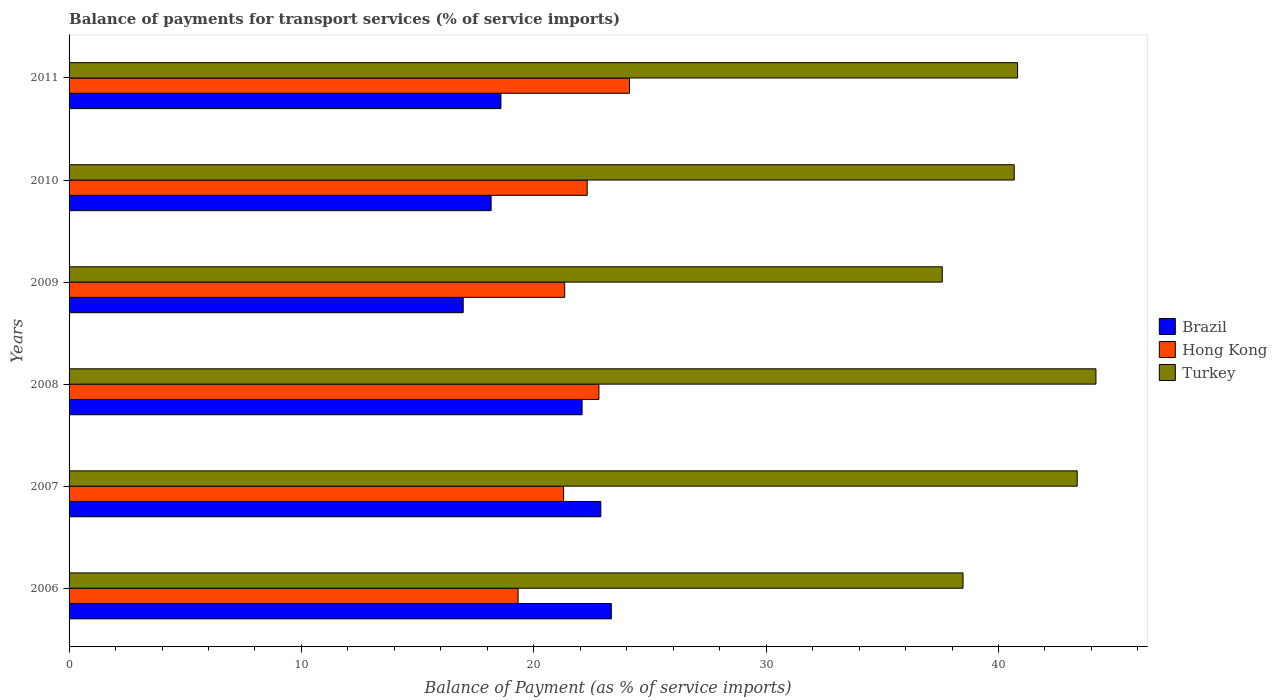How many bars are there on the 3rd tick from the top?
Offer a very short reply. 3. How many bars are there on the 1st tick from the bottom?
Your answer should be very brief. 3. What is the label of the 3rd group of bars from the top?
Make the answer very short. 2009. In how many cases, is the number of bars for a given year not equal to the number of legend labels?
Offer a very short reply. 0. What is the balance of payments for transport services in Brazil in 2007?
Make the answer very short. 22.89. Across all years, what is the maximum balance of payments for transport services in Hong Kong?
Provide a short and direct response. 24.12. Across all years, what is the minimum balance of payments for transport services in Turkey?
Your answer should be compact. 37.58. In which year was the balance of payments for transport services in Brazil maximum?
Make the answer very short. 2006. In which year was the balance of payments for transport services in Hong Kong minimum?
Provide a succinct answer. 2006. What is the total balance of payments for transport services in Hong Kong in the graph?
Keep it short and to the point. 131.16. What is the difference between the balance of payments for transport services in Hong Kong in 2007 and that in 2009?
Offer a terse response. -0.05. What is the difference between the balance of payments for transport services in Brazil in 2011 and the balance of payments for transport services in Hong Kong in 2007?
Give a very brief answer. -2.7. What is the average balance of payments for transport services in Turkey per year?
Offer a very short reply. 40.86. In the year 2011, what is the difference between the balance of payments for transport services in Brazil and balance of payments for transport services in Turkey?
Provide a succinct answer. -22.24. What is the ratio of the balance of payments for transport services in Brazil in 2007 to that in 2008?
Offer a very short reply. 1.04. Is the balance of payments for transport services in Turkey in 2007 less than that in 2011?
Offer a terse response. No. What is the difference between the highest and the second highest balance of payments for transport services in Turkey?
Provide a succinct answer. 0.81. What is the difference between the highest and the lowest balance of payments for transport services in Turkey?
Give a very brief answer. 6.61. What does the 2nd bar from the top in 2008 represents?
Provide a short and direct response. Hong Kong. What does the 2nd bar from the bottom in 2011 represents?
Make the answer very short. Hong Kong. How many bars are there?
Keep it short and to the point. 18. How many years are there in the graph?
Your answer should be very brief. 6. Are the values on the major ticks of X-axis written in scientific E-notation?
Your response must be concise. No. How many legend labels are there?
Your answer should be compact. 3. How are the legend labels stacked?
Make the answer very short. Vertical. What is the title of the graph?
Your answer should be compact. Balance of payments for transport services (% of service imports). What is the label or title of the X-axis?
Make the answer very short. Balance of Payment (as % of service imports). What is the label or title of the Y-axis?
Keep it short and to the point. Years. What is the Balance of Payment (as % of service imports) in Brazil in 2006?
Your response must be concise. 23.34. What is the Balance of Payment (as % of service imports) of Hong Kong in 2006?
Your response must be concise. 19.32. What is the Balance of Payment (as % of service imports) of Turkey in 2006?
Your answer should be very brief. 38.47. What is the Balance of Payment (as % of service imports) in Brazil in 2007?
Offer a very short reply. 22.89. What is the Balance of Payment (as % of service imports) of Hong Kong in 2007?
Give a very brief answer. 21.28. What is the Balance of Payment (as % of service imports) in Turkey in 2007?
Ensure brevity in your answer.  43.39. What is the Balance of Payment (as % of service imports) of Brazil in 2008?
Your answer should be compact. 22.08. What is the Balance of Payment (as % of service imports) in Hong Kong in 2008?
Provide a succinct answer. 22.8. What is the Balance of Payment (as % of service imports) in Turkey in 2008?
Your answer should be very brief. 44.2. What is the Balance of Payment (as % of service imports) in Brazil in 2009?
Make the answer very short. 16.96. What is the Balance of Payment (as % of service imports) of Hong Kong in 2009?
Your answer should be very brief. 21.33. What is the Balance of Payment (as % of service imports) in Turkey in 2009?
Provide a short and direct response. 37.58. What is the Balance of Payment (as % of service imports) in Brazil in 2010?
Give a very brief answer. 18.16. What is the Balance of Payment (as % of service imports) of Hong Kong in 2010?
Your response must be concise. 22.3. What is the Balance of Payment (as % of service imports) in Turkey in 2010?
Provide a short and direct response. 40.68. What is the Balance of Payment (as % of service imports) in Brazil in 2011?
Make the answer very short. 18.59. What is the Balance of Payment (as % of service imports) in Hong Kong in 2011?
Provide a succinct answer. 24.12. What is the Balance of Payment (as % of service imports) of Turkey in 2011?
Offer a very short reply. 40.82. Across all years, what is the maximum Balance of Payment (as % of service imports) in Brazil?
Your answer should be very brief. 23.34. Across all years, what is the maximum Balance of Payment (as % of service imports) of Hong Kong?
Keep it short and to the point. 24.12. Across all years, what is the maximum Balance of Payment (as % of service imports) of Turkey?
Provide a short and direct response. 44.2. Across all years, what is the minimum Balance of Payment (as % of service imports) of Brazil?
Your answer should be very brief. 16.96. Across all years, what is the minimum Balance of Payment (as % of service imports) in Hong Kong?
Ensure brevity in your answer.  19.32. Across all years, what is the minimum Balance of Payment (as % of service imports) in Turkey?
Provide a short and direct response. 37.58. What is the total Balance of Payment (as % of service imports) in Brazil in the graph?
Ensure brevity in your answer.  122.01. What is the total Balance of Payment (as % of service imports) in Hong Kong in the graph?
Make the answer very short. 131.16. What is the total Balance of Payment (as % of service imports) of Turkey in the graph?
Make the answer very short. 245.14. What is the difference between the Balance of Payment (as % of service imports) of Brazil in 2006 and that in 2007?
Your answer should be very brief. 0.45. What is the difference between the Balance of Payment (as % of service imports) in Hong Kong in 2006 and that in 2007?
Offer a terse response. -1.96. What is the difference between the Balance of Payment (as % of service imports) in Turkey in 2006 and that in 2007?
Ensure brevity in your answer.  -4.91. What is the difference between the Balance of Payment (as % of service imports) of Brazil in 2006 and that in 2008?
Your answer should be very brief. 1.26. What is the difference between the Balance of Payment (as % of service imports) in Hong Kong in 2006 and that in 2008?
Offer a very short reply. -3.48. What is the difference between the Balance of Payment (as % of service imports) in Turkey in 2006 and that in 2008?
Keep it short and to the point. -5.72. What is the difference between the Balance of Payment (as % of service imports) in Brazil in 2006 and that in 2009?
Keep it short and to the point. 6.37. What is the difference between the Balance of Payment (as % of service imports) of Hong Kong in 2006 and that in 2009?
Offer a terse response. -2.01. What is the difference between the Balance of Payment (as % of service imports) in Turkey in 2006 and that in 2009?
Give a very brief answer. 0.89. What is the difference between the Balance of Payment (as % of service imports) of Brazil in 2006 and that in 2010?
Your answer should be compact. 5.17. What is the difference between the Balance of Payment (as % of service imports) in Hong Kong in 2006 and that in 2010?
Your response must be concise. -2.97. What is the difference between the Balance of Payment (as % of service imports) in Turkey in 2006 and that in 2010?
Provide a succinct answer. -2.2. What is the difference between the Balance of Payment (as % of service imports) of Brazil in 2006 and that in 2011?
Provide a succinct answer. 4.75. What is the difference between the Balance of Payment (as % of service imports) in Hong Kong in 2006 and that in 2011?
Ensure brevity in your answer.  -4.79. What is the difference between the Balance of Payment (as % of service imports) in Turkey in 2006 and that in 2011?
Keep it short and to the point. -2.35. What is the difference between the Balance of Payment (as % of service imports) in Brazil in 2007 and that in 2008?
Ensure brevity in your answer.  0.81. What is the difference between the Balance of Payment (as % of service imports) of Hong Kong in 2007 and that in 2008?
Your response must be concise. -1.52. What is the difference between the Balance of Payment (as % of service imports) of Turkey in 2007 and that in 2008?
Your response must be concise. -0.81. What is the difference between the Balance of Payment (as % of service imports) in Brazil in 2007 and that in 2009?
Your response must be concise. 5.92. What is the difference between the Balance of Payment (as % of service imports) in Hong Kong in 2007 and that in 2009?
Offer a very short reply. -0.05. What is the difference between the Balance of Payment (as % of service imports) of Turkey in 2007 and that in 2009?
Provide a succinct answer. 5.81. What is the difference between the Balance of Payment (as % of service imports) of Brazil in 2007 and that in 2010?
Give a very brief answer. 4.72. What is the difference between the Balance of Payment (as % of service imports) of Hong Kong in 2007 and that in 2010?
Your response must be concise. -1.02. What is the difference between the Balance of Payment (as % of service imports) in Turkey in 2007 and that in 2010?
Make the answer very short. 2.71. What is the difference between the Balance of Payment (as % of service imports) of Brazil in 2007 and that in 2011?
Your response must be concise. 4.3. What is the difference between the Balance of Payment (as % of service imports) in Hong Kong in 2007 and that in 2011?
Your answer should be very brief. -2.84. What is the difference between the Balance of Payment (as % of service imports) of Turkey in 2007 and that in 2011?
Your response must be concise. 2.57. What is the difference between the Balance of Payment (as % of service imports) of Brazil in 2008 and that in 2009?
Keep it short and to the point. 5.12. What is the difference between the Balance of Payment (as % of service imports) of Hong Kong in 2008 and that in 2009?
Offer a very short reply. 1.47. What is the difference between the Balance of Payment (as % of service imports) of Turkey in 2008 and that in 2009?
Offer a terse response. 6.61. What is the difference between the Balance of Payment (as % of service imports) of Brazil in 2008 and that in 2010?
Offer a terse response. 3.92. What is the difference between the Balance of Payment (as % of service imports) of Hong Kong in 2008 and that in 2010?
Offer a very short reply. 0.51. What is the difference between the Balance of Payment (as % of service imports) of Turkey in 2008 and that in 2010?
Keep it short and to the point. 3.52. What is the difference between the Balance of Payment (as % of service imports) of Brazil in 2008 and that in 2011?
Ensure brevity in your answer.  3.49. What is the difference between the Balance of Payment (as % of service imports) of Hong Kong in 2008 and that in 2011?
Provide a short and direct response. -1.31. What is the difference between the Balance of Payment (as % of service imports) of Turkey in 2008 and that in 2011?
Make the answer very short. 3.37. What is the difference between the Balance of Payment (as % of service imports) of Brazil in 2009 and that in 2010?
Provide a short and direct response. -1.2. What is the difference between the Balance of Payment (as % of service imports) of Hong Kong in 2009 and that in 2010?
Provide a short and direct response. -0.97. What is the difference between the Balance of Payment (as % of service imports) of Turkey in 2009 and that in 2010?
Give a very brief answer. -3.1. What is the difference between the Balance of Payment (as % of service imports) in Brazil in 2009 and that in 2011?
Offer a terse response. -1.62. What is the difference between the Balance of Payment (as % of service imports) of Hong Kong in 2009 and that in 2011?
Provide a short and direct response. -2.79. What is the difference between the Balance of Payment (as % of service imports) in Turkey in 2009 and that in 2011?
Provide a short and direct response. -3.24. What is the difference between the Balance of Payment (as % of service imports) in Brazil in 2010 and that in 2011?
Provide a succinct answer. -0.42. What is the difference between the Balance of Payment (as % of service imports) of Hong Kong in 2010 and that in 2011?
Offer a very short reply. -1.82. What is the difference between the Balance of Payment (as % of service imports) in Turkey in 2010 and that in 2011?
Your answer should be compact. -0.15. What is the difference between the Balance of Payment (as % of service imports) of Brazil in 2006 and the Balance of Payment (as % of service imports) of Hong Kong in 2007?
Offer a very short reply. 2.05. What is the difference between the Balance of Payment (as % of service imports) in Brazil in 2006 and the Balance of Payment (as % of service imports) in Turkey in 2007?
Offer a very short reply. -20.05. What is the difference between the Balance of Payment (as % of service imports) in Hong Kong in 2006 and the Balance of Payment (as % of service imports) in Turkey in 2007?
Give a very brief answer. -24.06. What is the difference between the Balance of Payment (as % of service imports) of Brazil in 2006 and the Balance of Payment (as % of service imports) of Hong Kong in 2008?
Your response must be concise. 0.53. What is the difference between the Balance of Payment (as % of service imports) in Brazil in 2006 and the Balance of Payment (as % of service imports) in Turkey in 2008?
Your response must be concise. -20.86. What is the difference between the Balance of Payment (as % of service imports) in Hong Kong in 2006 and the Balance of Payment (as % of service imports) in Turkey in 2008?
Your response must be concise. -24.87. What is the difference between the Balance of Payment (as % of service imports) of Brazil in 2006 and the Balance of Payment (as % of service imports) of Hong Kong in 2009?
Give a very brief answer. 2.01. What is the difference between the Balance of Payment (as % of service imports) of Brazil in 2006 and the Balance of Payment (as % of service imports) of Turkey in 2009?
Ensure brevity in your answer.  -14.24. What is the difference between the Balance of Payment (as % of service imports) of Hong Kong in 2006 and the Balance of Payment (as % of service imports) of Turkey in 2009?
Offer a very short reply. -18.26. What is the difference between the Balance of Payment (as % of service imports) in Brazil in 2006 and the Balance of Payment (as % of service imports) in Turkey in 2010?
Provide a succinct answer. -17.34. What is the difference between the Balance of Payment (as % of service imports) in Hong Kong in 2006 and the Balance of Payment (as % of service imports) in Turkey in 2010?
Keep it short and to the point. -21.35. What is the difference between the Balance of Payment (as % of service imports) of Brazil in 2006 and the Balance of Payment (as % of service imports) of Hong Kong in 2011?
Offer a very short reply. -0.78. What is the difference between the Balance of Payment (as % of service imports) in Brazil in 2006 and the Balance of Payment (as % of service imports) in Turkey in 2011?
Offer a terse response. -17.49. What is the difference between the Balance of Payment (as % of service imports) in Hong Kong in 2006 and the Balance of Payment (as % of service imports) in Turkey in 2011?
Offer a very short reply. -21.5. What is the difference between the Balance of Payment (as % of service imports) in Brazil in 2007 and the Balance of Payment (as % of service imports) in Hong Kong in 2008?
Your answer should be compact. 0.08. What is the difference between the Balance of Payment (as % of service imports) in Brazil in 2007 and the Balance of Payment (as % of service imports) in Turkey in 2008?
Your answer should be compact. -21.31. What is the difference between the Balance of Payment (as % of service imports) of Hong Kong in 2007 and the Balance of Payment (as % of service imports) of Turkey in 2008?
Make the answer very short. -22.91. What is the difference between the Balance of Payment (as % of service imports) of Brazil in 2007 and the Balance of Payment (as % of service imports) of Hong Kong in 2009?
Your response must be concise. 1.55. What is the difference between the Balance of Payment (as % of service imports) of Brazil in 2007 and the Balance of Payment (as % of service imports) of Turkey in 2009?
Provide a succinct answer. -14.7. What is the difference between the Balance of Payment (as % of service imports) in Hong Kong in 2007 and the Balance of Payment (as % of service imports) in Turkey in 2009?
Your answer should be compact. -16.3. What is the difference between the Balance of Payment (as % of service imports) of Brazil in 2007 and the Balance of Payment (as % of service imports) of Hong Kong in 2010?
Offer a very short reply. 0.59. What is the difference between the Balance of Payment (as % of service imports) of Brazil in 2007 and the Balance of Payment (as % of service imports) of Turkey in 2010?
Provide a succinct answer. -17.79. What is the difference between the Balance of Payment (as % of service imports) in Hong Kong in 2007 and the Balance of Payment (as % of service imports) in Turkey in 2010?
Your answer should be compact. -19.39. What is the difference between the Balance of Payment (as % of service imports) in Brazil in 2007 and the Balance of Payment (as % of service imports) in Hong Kong in 2011?
Make the answer very short. -1.23. What is the difference between the Balance of Payment (as % of service imports) in Brazil in 2007 and the Balance of Payment (as % of service imports) in Turkey in 2011?
Make the answer very short. -17.94. What is the difference between the Balance of Payment (as % of service imports) in Hong Kong in 2007 and the Balance of Payment (as % of service imports) in Turkey in 2011?
Your response must be concise. -19.54. What is the difference between the Balance of Payment (as % of service imports) of Brazil in 2008 and the Balance of Payment (as % of service imports) of Hong Kong in 2009?
Make the answer very short. 0.75. What is the difference between the Balance of Payment (as % of service imports) in Brazil in 2008 and the Balance of Payment (as % of service imports) in Turkey in 2009?
Ensure brevity in your answer.  -15.5. What is the difference between the Balance of Payment (as % of service imports) in Hong Kong in 2008 and the Balance of Payment (as % of service imports) in Turkey in 2009?
Keep it short and to the point. -14.78. What is the difference between the Balance of Payment (as % of service imports) in Brazil in 2008 and the Balance of Payment (as % of service imports) in Hong Kong in 2010?
Offer a very short reply. -0.22. What is the difference between the Balance of Payment (as % of service imports) of Brazil in 2008 and the Balance of Payment (as % of service imports) of Turkey in 2010?
Give a very brief answer. -18.6. What is the difference between the Balance of Payment (as % of service imports) of Hong Kong in 2008 and the Balance of Payment (as % of service imports) of Turkey in 2010?
Keep it short and to the point. -17.87. What is the difference between the Balance of Payment (as % of service imports) in Brazil in 2008 and the Balance of Payment (as % of service imports) in Hong Kong in 2011?
Ensure brevity in your answer.  -2.04. What is the difference between the Balance of Payment (as % of service imports) in Brazil in 2008 and the Balance of Payment (as % of service imports) in Turkey in 2011?
Ensure brevity in your answer.  -18.74. What is the difference between the Balance of Payment (as % of service imports) of Hong Kong in 2008 and the Balance of Payment (as % of service imports) of Turkey in 2011?
Offer a terse response. -18.02. What is the difference between the Balance of Payment (as % of service imports) in Brazil in 2009 and the Balance of Payment (as % of service imports) in Hong Kong in 2010?
Give a very brief answer. -5.34. What is the difference between the Balance of Payment (as % of service imports) in Brazil in 2009 and the Balance of Payment (as % of service imports) in Turkey in 2010?
Your response must be concise. -23.71. What is the difference between the Balance of Payment (as % of service imports) of Hong Kong in 2009 and the Balance of Payment (as % of service imports) of Turkey in 2010?
Make the answer very short. -19.35. What is the difference between the Balance of Payment (as % of service imports) of Brazil in 2009 and the Balance of Payment (as % of service imports) of Hong Kong in 2011?
Offer a very short reply. -7.16. What is the difference between the Balance of Payment (as % of service imports) of Brazil in 2009 and the Balance of Payment (as % of service imports) of Turkey in 2011?
Your answer should be compact. -23.86. What is the difference between the Balance of Payment (as % of service imports) in Hong Kong in 2009 and the Balance of Payment (as % of service imports) in Turkey in 2011?
Provide a succinct answer. -19.49. What is the difference between the Balance of Payment (as % of service imports) in Brazil in 2010 and the Balance of Payment (as % of service imports) in Hong Kong in 2011?
Offer a very short reply. -5.96. What is the difference between the Balance of Payment (as % of service imports) in Brazil in 2010 and the Balance of Payment (as % of service imports) in Turkey in 2011?
Offer a terse response. -22.66. What is the difference between the Balance of Payment (as % of service imports) in Hong Kong in 2010 and the Balance of Payment (as % of service imports) in Turkey in 2011?
Ensure brevity in your answer.  -18.52. What is the average Balance of Payment (as % of service imports) in Brazil per year?
Provide a succinct answer. 20.34. What is the average Balance of Payment (as % of service imports) in Hong Kong per year?
Give a very brief answer. 21.86. What is the average Balance of Payment (as % of service imports) of Turkey per year?
Ensure brevity in your answer.  40.86. In the year 2006, what is the difference between the Balance of Payment (as % of service imports) in Brazil and Balance of Payment (as % of service imports) in Hong Kong?
Your response must be concise. 4.01. In the year 2006, what is the difference between the Balance of Payment (as % of service imports) of Brazil and Balance of Payment (as % of service imports) of Turkey?
Offer a terse response. -15.14. In the year 2006, what is the difference between the Balance of Payment (as % of service imports) of Hong Kong and Balance of Payment (as % of service imports) of Turkey?
Your answer should be very brief. -19.15. In the year 2007, what is the difference between the Balance of Payment (as % of service imports) of Brazil and Balance of Payment (as % of service imports) of Hong Kong?
Offer a terse response. 1.6. In the year 2007, what is the difference between the Balance of Payment (as % of service imports) of Brazil and Balance of Payment (as % of service imports) of Turkey?
Make the answer very short. -20.5. In the year 2007, what is the difference between the Balance of Payment (as % of service imports) in Hong Kong and Balance of Payment (as % of service imports) in Turkey?
Offer a very short reply. -22.1. In the year 2008, what is the difference between the Balance of Payment (as % of service imports) of Brazil and Balance of Payment (as % of service imports) of Hong Kong?
Your answer should be compact. -0.72. In the year 2008, what is the difference between the Balance of Payment (as % of service imports) of Brazil and Balance of Payment (as % of service imports) of Turkey?
Offer a terse response. -22.12. In the year 2008, what is the difference between the Balance of Payment (as % of service imports) in Hong Kong and Balance of Payment (as % of service imports) in Turkey?
Make the answer very short. -21.39. In the year 2009, what is the difference between the Balance of Payment (as % of service imports) in Brazil and Balance of Payment (as % of service imports) in Hong Kong?
Offer a very short reply. -4.37. In the year 2009, what is the difference between the Balance of Payment (as % of service imports) in Brazil and Balance of Payment (as % of service imports) in Turkey?
Keep it short and to the point. -20.62. In the year 2009, what is the difference between the Balance of Payment (as % of service imports) of Hong Kong and Balance of Payment (as % of service imports) of Turkey?
Your answer should be very brief. -16.25. In the year 2010, what is the difference between the Balance of Payment (as % of service imports) in Brazil and Balance of Payment (as % of service imports) in Hong Kong?
Offer a terse response. -4.13. In the year 2010, what is the difference between the Balance of Payment (as % of service imports) in Brazil and Balance of Payment (as % of service imports) in Turkey?
Offer a terse response. -22.51. In the year 2010, what is the difference between the Balance of Payment (as % of service imports) of Hong Kong and Balance of Payment (as % of service imports) of Turkey?
Your answer should be very brief. -18.38. In the year 2011, what is the difference between the Balance of Payment (as % of service imports) of Brazil and Balance of Payment (as % of service imports) of Hong Kong?
Offer a very short reply. -5.53. In the year 2011, what is the difference between the Balance of Payment (as % of service imports) of Brazil and Balance of Payment (as % of service imports) of Turkey?
Offer a terse response. -22.24. In the year 2011, what is the difference between the Balance of Payment (as % of service imports) of Hong Kong and Balance of Payment (as % of service imports) of Turkey?
Your answer should be compact. -16.7. What is the ratio of the Balance of Payment (as % of service imports) of Brazil in 2006 to that in 2007?
Give a very brief answer. 1.02. What is the ratio of the Balance of Payment (as % of service imports) in Hong Kong in 2006 to that in 2007?
Keep it short and to the point. 0.91. What is the ratio of the Balance of Payment (as % of service imports) in Turkey in 2006 to that in 2007?
Provide a succinct answer. 0.89. What is the ratio of the Balance of Payment (as % of service imports) of Brazil in 2006 to that in 2008?
Your answer should be very brief. 1.06. What is the ratio of the Balance of Payment (as % of service imports) in Hong Kong in 2006 to that in 2008?
Keep it short and to the point. 0.85. What is the ratio of the Balance of Payment (as % of service imports) in Turkey in 2006 to that in 2008?
Keep it short and to the point. 0.87. What is the ratio of the Balance of Payment (as % of service imports) of Brazil in 2006 to that in 2009?
Offer a terse response. 1.38. What is the ratio of the Balance of Payment (as % of service imports) of Hong Kong in 2006 to that in 2009?
Your answer should be very brief. 0.91. What is the ratio of the Balance of Payment (as % of service imports) in Turkey in 2006 to that in 2009?
Your answer should be compact. 1.02. What is the ratio of the Balance of Payment (as % of service imports) in Brazil in 2006 to that in 2010?
Ensure brevity in your answer.  1.28. What is the ratio of the Balance of Payment (as % of service imports) in Hong Kong in 2006 to that in 2010?
Your response must be concise. 0.87. What is the ratio of the Balance of Payment (as % of service imports) of Turkey in 2006 to that in 2010?
Provide a short and direct response. 0.95. What is the ratio of the Balance of Payment (as % of service imports) of Brazil in 2006 to that in 2011?
Your answer should be very brief. 1.26. What is the ratio of the Balance of Payment (as % of service imports) in Hong Kong in 2006 to that in 2011?
Your answer should be very brief. 0.8. What is the ratio of the Balance of Payment (as % of service imports) in Turkey in 2006 to that in 2011?
Provide a succinct answer. 0.94. What is the ratio of the Balance of Payment (as % of service imports) in Brazil in 2007 to that in 2008?
Give a very brief answer. 1.04. What is the ratio of the Balance of Payment (as % of service imports) of Hong Kong in 2007 to that in 2008?
Your answer should be very brief. 0.93. What is the ratio of the Balance of Payment (as % of service imports) of Turkey in 2007 to that in 2008?
Provide a short and direct response. 0.98. What is the ratio of the Balance of Payment (as % of service imports) of Brazil in 2007 to that in 2009?
Keep it short and to the point. 1.35. What is the ratio of the Balance of Payment (as % of service imports) in Turkey in 2007 to that in 2009?
Provide a short and direct response. 1.15. What is the ratio of the Balance of Payment (as % of service imports) in Brazil in 2007 to that in 2010?
Give a very brief answer. 1.26. What is the ratio of the Balance of Payment (as % of service imports) in Hong Kong in 2007 to that in 2010?
Your response must be concise. 0.95. What is the ratio of the Balance of Payment (as % of service imports) in Turkey in 2007 to that in 2010?
Provide a short and direct response. 1.07. What is the ratio of the Balance of Payment (as % of service imports) in Brazil in 2007 to that in 2011?
Provide a succinct answer. 1.23. What is the ratio of the Balance of Payment (as % of service imports) in Hong Kong in 2007 to that in 2011?
Offer a very short reply. 0.88. What is the ratio of the Balance of Payment (as % of service imports) of Turkey in 2007 to that in 2011?
Ensure brevity in your answer.  1.06. What is the ratio of the Balance of Payment (as % of service imports) in Brazil in 2008 to that in 2009?
Give a very brief answer. 1.3. What is the ratio of the Balance of Payment (as % of service imports) in Hong Kong in 2008 to that in 2009?
Your answer should be very brief. 1.07. What is the ratio of the Balance of Payment (as % of service imports) in Turkey in 2008 to that in 2009?
Give a very brief answer. 1.18. What is the ratio of the Balance of Payment (as % of service imports) in Brazil in 2008 to that in 2010?
Give a very brief answer. 1.22. What is the ratio of the Balance of Payment (as % of service imports) of Hong Kong in 2008 to that in 2010?
Your answer should be compact. 1.02. What is the ratio of the Balance of Payment (as % of service imports) in Turkey in 2008 to that in 2010?
Make the answer very short. 1.09. What is the ratio of the Balance of Payment (as % of service imports) of Brazil in 2008 to that in 2011?
Offer a very short reply. 1.19. What is the ratio of the Balance of Payment (as % of service imports) of Hong Kong in 2008 to that in 2011?
Provide a succinct answer. 0.95. What is the ratio of the Balance of Payment (as % of service imports) of Turkey in 2008 to that in 2011?
Your answer should be compact. 1.08. What is the ratio of the Balance of Payment (as % of service imports) in Brazil in 2009 to that in 2010?
Offer a terse response. 0.93. What is the ratio of the Balance of Payment (as % of service imports) of Hong Kong in 2009 to that in 2010?
Provide a succinct answer. 0.96. What is the ratio of the Balance of Payment (as % of service imports) in Turkey in 2009 to that in 2010?
Provide a succinct answer. 0.92. What is the ratio of the Balance of Payment (as % of service imports) in Brazil in 2009 to that in 2011?
Ensure brevity in your answer.  0.91. What is the ratio of the Balance of Payment (as % of service imports) of Hong Kong in 2009 to that in 2011?
Provide a short and direct response. 0.88. What is the ratio of the Balance of Payment (as % of service imports) in Turkey in 2009 to that in 2011?
Provide a succinct answer. 0.92. What is the ratio of the Balance of Payment (as % of service imports) in Brazil in 2010 to that in 2011?
Provide a short and direct response. 0.98. What is the ratio of the Balance of Payment (as % of service imports) in Hong Kong in 2010 to that in 2011?
Your answer should be very brief. 0.92. What is the ratio of the Balance of Payment (as % of service imports) of Turkey in 2010 to that in 2011?
Keep it short and to the point. 1. What is the difference between the highest and the second highest Balance of Payment (as % of service imports) of Brazil?
Your response must be concise. 0.45. What is the difference between the highest and the second highest Balance of Payment (as % of service imports) of Hong Kong?
Provide a succinct answer. 1.31. What is the difference between the highest and the second highest Balance of Payment (as % of service imports) in Turkey?
Offer a terse response. 0.81. What is the difference between the highest and the lowest Balance of Payment (as % of service imports) in Brazil?
Keep it short and to the point. 6.37. What is the difference between the highest and the lowest Balance of Payment (as % of service imports) of Hong Kong?
Offer a very short reply. 4.79. What is the difference between the highest and the lowest Balance of Payment (as % of service imports) in Turkey?
Your answer should be very brief. 6.61. 